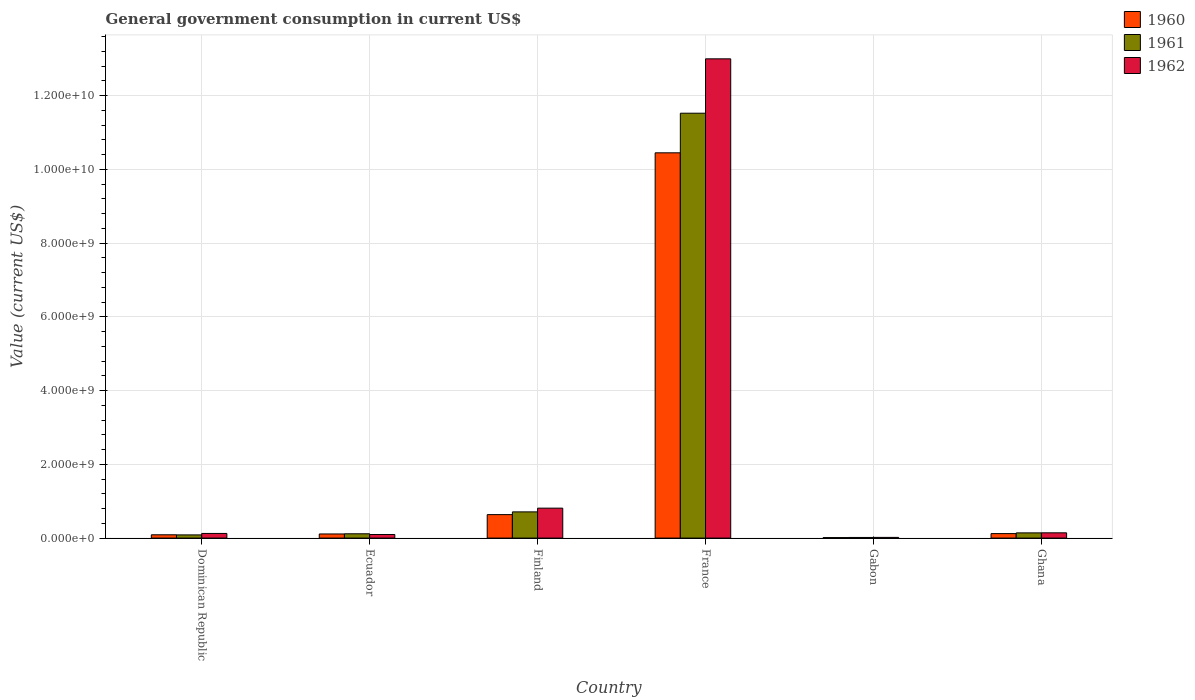How many different coloured bars are there?
Give a very brief answer. 3. Are the number of bars per tick equal to the number of legend labels?
Ensure brevity in your answer.  Yes. What is the label of the 6th group of bars from the left?
Your answer should be compact. Ghana. In how many cases, is the number of bars for a given country not equal to the number of legend labels?
Provide a succinct answer. 0. What is the government conusmption in 1962 in Ecuador?
Your answer should be compact. 9.72e+07. Across all countries, what is the maximum government conusmption in 1960?
Your response must be concise. 1.05e+1. Across all countries, what is the minimum government conusmption in 1962?
Your answer should be very brief. 1.86e+07. In which country was the government conusmption in 1960 maximum?
Keep it short and to the point. France. In which country was the government conusmption in 1961 minimum?
Ensure brevity in your answer.  Gabon. What is the total government conusmption in 1960 in the graph?
Provide a short and direct response. 1.14e+1. What is the difference between the government conusmption in 1961 in Finland and that in France?
Make the answer very short. -1.08e+1. What is the difference between the government conusmption in 1961 in Dominican Republic and the government conusmption in 1960 in Ecuador?
Keep it short and to the point. -2.52e+07. What is the average government conusmption in 1962 per country?
Your answer should be compact. 2.37e+09. What is the difference between the government conusmption of/in 1962 and government conusmption of/in 1960 in France?
Provide a short and direct response. 2.55e+09. In how many countries, is the government conusmption in 1962 greater than 2800000000 US$?
Provide a short and direct response. 1. What is the ratio of the government conusmption in 1962 in Finland to that in Gabon?
Make the answer very short. 43.55. What is the difference between the highest and the second highest government conusmption in 1962?
Provide a succinct answer. 6.69e+08. What is the difference between the highest and the lowest government conusmption in 1962?
Provide a short and direct response. 1.30e+1. In how many countries, is the government conusmption in 1961 greater than the average government conusmption in 1961 taken over all countries?
Make the answer very short. 1. Is the sum of the government conusmption in 1962 in Finland and Gabon greater than the maximum government conusmption in 1961 across all countries?
Make the answer very short. No. What does the 1st bar from the left in Gabon represents?
Offer a very short reply. 1960. Is it the case that in every country, the sum of the government conusmption in 1962 and government conusmption in 1961 is greater than the government conusmption in 1960?
Your response must be concise. Yes. How many bars are there?
Offer a terse response. 18. How many countries are there in the graph?
Your response must be concise. 6. What is the difference between two consecutive major ticks on the Y-axis?
Provide a succinct answer. 2.00e+09. Are the values on the major ticks of Y-axis written in scientific E-notation?
Offer a very short reply. Yes. Does the graph contain any zero values?
Ensure brevity in your answer.  No. Where does the legend appear in the graph?
Offer a very short reply. Top right. What is the title of the graph?
Offer a terse response. General government consumption in current US$. Does "1977" appear as one of the legend labels in the graph?
Your response must be concise. No. What is the label or title of the Y-axis?
Your answer should be compact. Value (current US$). What is the Value (current US$) in 1960 in Dominican Republic?
Your response must be concise. 8.95e+07. What is the Value (current US$) of 1961 in Dominican Republic?
Provide a short and direct response. 8.68e+07. What is the Value (current US$) of 1962 in Dominican Republic?
Offer a very short reply. 1.26e+08. What is the Value (current US$) in 1960 in Ecuador?
Provide a short and direct response. 1.12e+08. What is the Value (current US$) of 1961 in Ecuador?
Your answer should be compact. 1.17e+08. What is the Value (current US$) in 1962 in Ecuador?
Provide a succinct answer. 9.72e+07. What is the Value (current US$) of 1960 in Finland?
Your response must be concise. 6.37e+08. What is the Value (current US$) in 1961 in Finland?
Provide a short and direct response. 7.11e+08. What is the Value (current US$) of 1962 in Finland?
Offer a very short reply. 8.12e+08. What is the Value (current US$) in 1960 in France?
Make the answer very short. 1.05e+1. What is the Value (current US$) of 1961 in France?
Your answer should be compact. 1.15e+1. What is the Value (current US$) in 1962 in France?
Keep it short and to the point. 1.30e+1. What is the Value (current US$) in 1960 in Gabon?
Provide a succinct answer. 1.38e+07. What is the Value (current US$) in 1961 in Gabon?
Offer a terse response. 1.72e+07. What is the Value (current US$) in 1962 in Gabon?
Provide a short and direct response. 1.86e+07. What is the Value (current US$) in 1960 in Ghana?
Your response must be concise. 1.22e+08. What is the Value (current US$) in 1961 in Ghana?
Give a very brief answer. 1.41e+08. What is the Value (current US$) of 1962 in Ghana?
Offer a terse response. 1.43e+08. Across all countries, what is the maximum Value (current US$) in 1960?
Give a very brief answer. 1.05e+1. Across all countries, what is the maximum Value (current US$) in 1961?
Keep it short and to the point. 1.15e+1. Across all countries, what is the maximum Value (current US$) of 1962?
Your response must be concise. 1.30e+1. Across all countries, what is the minimum Value (current US$) in 1960?
Make the answer very short. 1.38e+07. Across all countries, what is the minimum Value (current US$) in 1961?
Make the answer very short. 1.72e+07. Across all countries, what is the minimum Value (current US$) in 1962?
Keep it short and to the point. 1.86e+07. What is the total Value (current US$) in 1960 in the graph?
Your answer should be very brief. 1.14e+1. What is the total Value (current US$) of 1961 in the graph?
Give a very brief answer. 1.26e+1. What is the total Value (current US$) of 1962 in the graph?
Provide a succinct answer. 1.42e+1. What is the difference between the Value (current US$) of 1960 in Dominican Republic and that in Ecuador?
Make the answer very short. -2.25e+07. What is the difference between the Value (current US$) in 1961 in Dominican Republic and that in Ecuador?
Keep it short and to the point. -2.99e+07. What is the difference between the Value (current US$) of 1962 in Dominican Republic and that in Ecuador?
Offer a terse response. 2.89e+07. What is the difference between the Value (current US$) in 1960 in Dominican Republic and that in Finland?
Provide a succinct answer. -5.47e+08. What is the difference between the Value (current US$) of 1961 in Dominican Republic and that in Finland?
Your answer should be compact. -6.24e+08. What is the difference between the Value (current US$) in 1962 in Dominican Republic and that in Finland?
Keep it short and to the point. -6.86e+08. What is the difference between the Value (current US$) in 1960 in Dominican Republic and that in France?
Provide a short and direct response. -1.04e+1. What is the difference between the Value (current US$) of 1961 in Dominican Republic and that in France?
Provide a short and direct response. -1.14e+1. What is the difference between the Value (current US$) in 1962 in Dominican Republic and that in France?
Your answer should be compact. -1.29e+1. What is the difference between the Value (current US$) in 1960 in Dominican Republic and that in Gabon?
Make the answer very short. 7.57e+07. What is the difference between the Value (current US$) of 1961 in Dominican Republic and that in Gabon?
Ensure brevity in your answer.  6.96e+07. What is the difference between the Value (current US$) in 1962 in Dominican Republic and that in Gabon?
Keep it short and to the point. 1.07e+08. What is the difference between the Value (current US$) in 1960 in Dominican Republic and that in Ghana?
Ensure brevity in your answer.  -3.24e+07. What is the difference between the Value (current US$) of 1961 in Dominican Republic and that in Ghana?
Offer a terse response. -5.47e+07. What is the difference between the Value (current US$) of 1962 in Dominican Republic and that in Ghana?
Make the answer very short. -1.68e+07. What is the difference between the Value (current US$) in 1960 in Ecuador and that in Finland?
Offer a very short reply. -5.25e+08. What is the difference between the Value (current US$) in 1961 in Ecuador and that in Finland?
Keep it short and to the point. -5.94e+08. What is the difference between the Value (current US$) in 1962 in Ecuador and that in Finland?
Offer a terse response. -7.15e+08. What is the difference between the Value (current US$) in 1960 in Ecuador and that in France?
Ensure brevity in your answer.  -1.03e+1. What is the difference between the Value (current US$) in 1961 in Ecuador and that in France?
Keep it short and to the point. -1.14e+1. What is the difference between the Value (current US$) of 1962 in Ecuador and that in France?
Your answer should be compact. -1.29e+1. What is the difference between the Value (current US$) in 1960 in Ecuador and that in Gabon?
Offer a terse response. 9.82e+07. What is the difference between the Value (current US$) of 1961 in Ecuador and that in Gabon?
Ensure brevity in your answer.  9.95e+07. What is the difference between the Value (current US$) in 1962 in Ecuador and that in Gabon?
Ensure brevity in your answer.  7.86e+07. What is the difference between the Value (current US$) of 1960 in Ecuador and that in Ghana?
Keep it short and to the point. -9.85e+06. What is the difference between the Value (current US$) of 1961 in Ecuador and that in Ghana?
Provide a short and direct response. -2.48e+07. What is the difference between the Value (current US$) in 1962 in Ecuador and that in Ghana?
Give a very brief answer. -4.56e+07. What is the difference between the Value (current US$) in 1960 in Finland and that in France?
Keep it short and to the point. -9.81e+09. What is the difference between the Value (current US$) of 1961 in Finland and that in France?
Keep it short and to the point. -1.08e+1. What is the difference between the Value (current US$) of 1962 in Finland and that in France?
Ensure brevity in your answer.  -1.22e+1. What is the difference between the Value (current US$) of 1960 in Finland and that in Gabon?
Ensure brevity in your answer.  6.23e+08. What is the difference between the Value (current US$) of 1961 in Finland and that in Gabon?
Make the answer very short. 6.94e+08. What is the difference between the Value (current US$) in 1962 in Finland and that in Gabon?
Keep it short and to the point. 7.94e+08. What is the difference between the Value (current US$) in 1960 in Finland and that in Ghana?
Your answer should be compact. 5.15e+08. What is the difference between the Value (current US$) in 1961 in Finland and that in Ghana?
Your answer should be very brief. 5.69e+08. What is the difference between the Value (current US$) in 1962 in Finland and that in Ghana?
Keep it short and to the point. 6.69e+08. What is the difference between the Value (current US$) of 1960 in France and that in Gabon?
Your answer should be very brief. 1.04e+1. What is the difference between the Value (current US$) in 1961 in France and that in Gabon?
Offer a terse response. 1.15e+1. What is the difference between the Value (current US$) in 1962 in France and that in Gabon?
Offer a very short reply. 1.30e+1. What is the difference between the Value (current US$) in 1960 in France and that in Ghana?
Your response must be concise. 1.03e+1. What is the difference between the Value (current US$) of 1961 in France and that in Ghana?
Make the answer very short. 1.14e+1. What is the difference between the Value (current US$) in 1962 in France and that in Ghana?
Your response must be concise. 1.29e+1. What is the difference between the Value (current US$) of 1960 in Gabon and that in Ghana?
Your answer should be very brief. -1.08e+08. What is the difference between the Value (current US$) in 1961 in Gabon and that in Ghana?
Ensure brevity in your answer.  -1.24e+08. What is the difference between the Value (current US$) of 1962 in Gabon and that in Ghana?
Provide a succinct answer. -1.24e+08. What is the difference between the Value (current US$) of 1960 in Dominican Republic and the Value (current US$) of 1961 in Ecuador?
Ensure brevity in your answer.  -2.72e+07. What is the difference between the Value (current US$) of 1960 in Dominican Republic and the Value (current US$) of 1962 in Ecuador?
Give a very brief answer. -7.73e+06. What is the difference between the Value (current US$) in 1961 in Dominican Republic and the Value (current US$) in 1962 in Ecuador?
Your answer should be very brief. -1.04e+07. What is the difference between the Value (current US$) in 1960 in Dominican Republic and the Value (current US$) in 1961 in Finland?
Provide a short and direct response. -6.21e+08. What is the difference between the Value (current US$) in 1960 in Dominican Republic and the Value (current US$) in 1962 in Finland?
Your answer should be compact. -7.23e+08. What is the difference between the Value (current US$) in 1961 in Dominican Republic and the Value (current US$) in 1962 in Finland?
Offer a very short reply. -7.25e+08. What is the difference between the Value (current US$) of 1960 in Dominican Republic and the Value (current US$) of 1961 in France?
Your response must be concise. -1.14e+1. What is the difference between the Value (current US$) in 1960 in Dominican Republic and the Value (current US$) in 1962 in France?
Offer a terse response. -1.29e+1. What is the difference between the Value (current US$) of 1961 in Dominican Republic and the Value (current US$) of 1962 in France?
Keep it short and to the point. -1.29e+1. What is the difference between the Value (current US$) of 1960 in Dominican Republic and the Value (current US$) of 1961 in Gabon?
Offer a very short reply. 7.23e+07. What is the difference between the Value (current US$) in 1960 in Dominican Republic and the Value (current US$) in 1962 in Gabon?
Provide a short and direct response. 7.09e+07. What is the difference between the Value (current US$) of 1961 in Dominican Republic and the Value (current US$) of 1962 in Gabon?
Offer a very short reply. 6.82e+07. What is the difference between the Value (current US$) in 1960 in Dominican Republic and the Value (current US$) in 1961 in Ghana?
Your answer should be very brief. -5.20e+07. What is the difference between the Value (current US$) in 1960 in Dominican Republic and the Value (current US$) in 1962 in Ghana?
Provide a succinct answer. -5.34e+07. What is the difference between the Value (current US$) of 1961 in Dominican Republic and the Value (current US$) of 1962 in Ghana?
Make the answer very short. -5.61e+07. What is the difference between the Value (current US$) in 1960 in Ecuador and the Value (current US$) in 1961 in Finland?
Your answer should be very brief. -5.99e+08. What is the difference between the Value (current US$) of 1960 in Ecuador and the Value (current US$) of 1962 in Finland?
Provide a succinct answer. -7.00e+08. What is the difference between the Value (current US$) of 1961 in Ecuador and the Value (current US$) of 1962 in Finland?
Keep it short and to the point. -6.95e+08. What is the difference between the Value (current US$) in 1960 in Ecuador and the Value (current US$) in 1961 in France?
Keep it short and to the point. -1.14e+1. What is the difference between the Value (current US$) in 1960 in Ecuador and the Value (current US$) in 1962 in France?
Your answer should be compact. -1.29e+1. What is the difference between the Value (current US$) in 1961 in Ecuador and the Value (current US$) in 1962 in France?
Keep it short and to the point. -1.29e+1. What is the difference between the Value (current US$) of 1960 in Ecuador and the Value (current US$) of 1961 in Gabon?
Your response must be concise. 9.48e+07. What is the difference between the Value (current US$) in 1960 in Ecuador and the Value (current US$) in 1962 in Gabon?
Offer a very short reply. 9.34e+07. What is the difference between the Value (current US$) in 1961 in Ecuador and the Value (current US$) in 1962 in Gabon?
Give a very brief answer. 9.80e+07. What is the difference between the Value (current US$) of 1960 in Ecuador and the Value (current US$) of 1961 in Ghana?
Your response must be concise. -2.95e+07. What is the difference between the Value (current US$) of 1960 in Ecuador and the Value (current US$) of 1962 in Ghana?
Provide a succinct answer. -3.09e+07. What is the difference between the Value (current US$) of 1961 in Ecuador and the Value (current US$) of 1962 in Ghana?
Your answer should be very brief. -2.62e+07. What is the difference between the Value (current US$) of 1960 in Finland and the Value (current US$) of 1961 in France?
Your response must be concise. -1.09e+1. What is the difference between the Value (current US$) of 1960 in Finland and the Value (current US$) of 1962 in France?
Ensure brevity in your answer.  -1.24e+1. What is the difference between the Value (current US$) of 1961 in Finland and the Value (current US$) of 1962 in France?
Offer a very short reply. -1.23e+1. What is the difference between the Value (current US$) of 1960 in Finland and the Value (current US$) of 1961 in Gabon?
Your response must be concise. 6.20e+08. What is the difference between the Value (current US$) of 1960 in Finland and the Value (current US$) of 1962 in Gabon?
Your response must be concise. 6.18e+08. What is the difference between the Value (current US$) of 1961 in Finland and the Value (current US$) of 1962 in Gabon?
Keep it short and to the point. 6.92e+08. What is the difference between the Value (current US$) in 1960 in Finland and the Value (current US$) in 1961 in Ghana?
Keep it short and to the point. 4.95e+08. What is the difference between the Value (current US$) in 1960 in Finland and the Value (current US$) in 1962 in Ghana?
Give a very brief answer. 4.94e+08. What is the difference between the Value (current US$) of 1961 in Finland and the Value (current US$) of 1962 in Ghana?
Keep it short and to the point. 5.68e+08. What is the difference between the Value (current US$) in 1960 in France and the Value (current US$) in 1961 in Gabon?
Offer a terse response. 1.04e+1. What is the difference between the Value (current US$) of 1960 in France and the Value (current US$) of 1962 in Gabon?
Offer a very short reply. 1.04e+1. What is the difference between the Value (current US$) in 1961 in France and the Value (current US$) in 1962 in Gabon?
Offer a very short reply. 1.15e+1. What is the difference between the Value (current US$) in 1960 in France and the Value (current US$) in 1961 in Ghana?
Offer a terse response. 1.03e+1. What is the difference between the Value (current US$) of 1960 in France and the Value (current US$) of 1962 in Ghana?
Provide a short and direct response. 1.03e+1. What is the difference between the Value (current US$) of 1961 in France and the Value (current US$) of 1962 in Ghana?
Your answer should be very brief. 1.14e+1. What is the difference between the Value (current US$) of 1960 in Gabon and the Value (current US$) of 1961 in Ghana?
Give a very brief answer. -1.28e+08. What is the difference between the Value (current US$) of 1960 in Gabon and the Value (current US$) of 1962 in Ghana?
Your response must be concise. -1.29e+08. What is the difference between the Value (current US$) in 1961 in Gabon and the Value (current US$) in 1962 in Ghana?
Keep it short and to the point. -1.26e+08. What is the average Value (current US$) in 1960 per country?
Offer a very short reply. 1.90e+09. What is the average Value (current US$) of 1961 per country?
Make the answer very short. 2.10e+09. What is the average Value (current US$) in 1962 per country?
Your response must be concise. 2.37e+09. What is the difference between the Value (current US$) of 1960 and Value (current US$) of 1961 in Dominican Republic?
Make the answer very short. 2.70e+06. What is the difference between the Value (current US$) of 1960 and Value (current US$) of 1962 in Dominican Republic?
Your response must be concise. -3.66e+07. What is the difference between the Value (current US$) in 1961 and Value (current US$) in 1962 in Dominican Republic?
Your answer should be very brief. -3.93e+07. What is the difference between the Value (current US$) in 1960 and Value (current US$) in 1961 in Ecuador?
Make the answer very short. -4.67e+06. What is the difference between the Value (current US$) of 1960 and Value (current US$) of 1962 in Ecuador?
Keep it short and to the point. 1.48e+07. What is the difference between the Value (current US$) of 1961 and Value (current US$) of 1962 in Ecuador?
Offer a very short reply. 1.94e+07. What is the difference between the Value (current US$) of 1960 and Value (current US$) of 1961 in Finland?
Your response must be concise. -7.42e+07. What is the difference between the Value (current US$) in 1960 and Value (current US$) in 1962 in Finland?
Give a very brief answer. -1.75e+08. What is the difference between the Value (current US$) of 1961 and Value (current US$) of 1962 in Finland?
Ensure brevity in your answer.  -1.01e+08. What is the difference between the Value (current US$) of 1960 and Value (current US$) of 1961 in France?
Give a very brief answer. -1.07e+09. What is the difference between the Value (current US$) in 1960 and Value (current US$) in 1962 in France?
Your response must be concise. -2.55e+09. What is the difference between the Value (current US$) in 1961 and Value (current US$) in 1962 in France?
Provide a succinct answer. -1.48e+09. What is the difference between the Value (current US$) in 1960 and Value (current US$) in 1961 in Gabon?
Your response must be concise. -3.38e+06. What is the difference between the Value (current US$) in 1960 and Value (current US$) in 1962 in Gabon?
Your answer should be compact. -4.81e+06. What is the difference between the Value (current US$) in 1961 and Value (current US$) in 1962 in Gabon?
Offer a very short reply. -1.43e+06. What is the difference between the Value (current US$) in 1960 and Value (current US$) in 1961 in Ghana?
Your response must be concise. -1.96e+07. What is the difference between the Value (current US$) in 1960 and Value (current US$) in 1962 in Ghana?
Make the answer very short. -2.10e+07. What is the difference between the Value (current US$) in 1961 and Value (current US$) in 1962 in Ghana?
Offer a very short reply. -1.40e+06. What is the ratio of the Value (current US$) in 1960 in Dominican Republic to that in Ecuador?
Keep it short and to the point. 0.8. What is the ratio of the Value (current US$) in 1961 in Dominican Republic to that in Ecuador?
Provide a short and direct response. 0.74. What is the ratio of the Value (current US$) of 1962 in Dominican Republic to that in Ecuador?
Your answer should be compact. 1.3. What is the ratio of the Value (current US$) in 1960 in Dominican Republic to that in Finland?
Ensure brevity in your answer.  0.14. What is the ratio of the Value (current US$) of 1961 in Dominican Republic to that in Finland?
Ensure brevity in your answer.  0.12. What is the ratio of the Value (current US$) in 1962 in Dominican Republic to that in Finland?
Offer a terse response. 0.16. What is the ratio of the Value (current US$) in 1960 in Dominican Republic to that in France?
Offer a terse response. 0.01. What is the ratio of the Value (current US$) of 1961 in Dominican Republic to that in France?
Your response must be concise. 0.01. What is the ratio of the Value (current US$) in 1962 in Dominican Republic to that in France?
Keep it short and to the point. 0.01. What is the ratio of the Value (current US$) of 1960 in Dominican Republic to that in Gabon?
Offer a very short reply. 6.47. What is the ratio of the Value (current US$) of 1961 in Dominican Republic to that in Gabon?
Keep it short and to the point. 5.04. What is the ratio of the Value (current US$) of 1962 in Dominican Republic to that in Gabon?
Offer a terse response. 6.76. What is the ratio of the Value (current US$) in 1960 in Dominican Republic to that in Ghana?
Your answer should be very brief. 0.73. What is the ratio of the Value (current US$) in 1961 in Dominican Republic to that in Ghana?
Provide a short and direct response. 0.61. What is the ratio of the Value (current US$) of 1962 in Dominican Republic to that in Ghana?
Ensure brevity in your answer.  0.88. What is the ratio of the Value (current US$) of 1960 in Ecuador to that in Finland?
Your answer should be compact. 0.18. What is the ratio of the Value (current US$) of 1961 in Ecuador to that in Finland?
Make the answer very short. 0.16. What is the ratio of the Value (current US$) in 1962 in Ecuador to that in Finland?
Your answer should be compact. 0.12. What is the ratio of the Value (current US$) of 1960 in Ecuador to that in France?
Your answer should be compact. 0.01. What is the ratio of the Value (current US$) in 1961 in Ecuador to that in France?
Offer a terse response. 0.01. What is the ratio of the Value (current US$) in 1962 in Ecuador to that in France?
Offer a very short reply. 0.01. What is the ratio of the Value (current US$) of 1960 in Ecuador to that in Gabon?
Offer a very short reply. 8.1. What is the ratio of the Value (current US$) of 1961 in Ecuador to that in Gabon?
Make the answer very short. 6.78. What is the ratio of the Value (current US$) in 1962 in Ecuador to that in Gabon?
Make the answer very short. 5.21. What is the ratio of the Value (current US$) in 1960 in Ecuador to that in Ghana?
Provide a succinct answer. 0.92. What is the ratio of the Value (current US$) in 1961 in Ecuador to that in Ghana?
Your response must be concise. 0.82. What is the ratio of the Value (current US$) in 1962 in Ecuador to that in Ghana?
Offer a terse response. 0.68. What is the ratio of the Value (current US$) of 1960 in Finland to that in France?
Your response must be concise. 0.06. What is the ratio of the Value (current US$) in 1961 in Finland to that in France?
Provide a short and direct response. 0.06. What is the ratio of the Value (current US$) in 1962 in Finland to that in France?
Make the answer very short. 0.06. What is the ratio of the Value (current US$) of 1960 in Finland to that in Gabon?
Make the answer very short. 46.02. What is the ratio of the Value (current US$) in 1961 in Finland to that in Gabon?
Make the answer very short. 41.29. What is the ratio of the Value (current US$) of 1962 in Finland to that in Gabon?
Make the answer very short. 43.55. What is the ratio of the Value (current US$) in 1960 in Finland to that in Ghana?
Make the answer very short. 5.22. What is the ratio of the Value (current US$) in 1961 in Finland to that in Ghana?
Your answer should be very brief. 5.03. What is the ratio of the Value (current US$) in 1962 in Finland to that in Ghana?
Make the answer very short. 5.68. What is the ratio of the Value (current US$) in 1960 in France to that in Gabon?
Offer a very short reply. 755.44. What is the ratio of the Value (current US$) in 1961 in France to that in Gabon?
Provide a short and direct response. 669.38. What is the ratio of the Value (current US$) in 1962 in France to that in Gabon?
Give a very brief answer. 697.15. What is the ratio of the Value (current US$) of 1960 in France to that in Ghana?
Your answer should be very brief. 85.77. What is the ratio of the Value (current US$) of 1961 in France to that in Ghana?
Keep it short and to the point. 81.47. What is the ratio of the Value (current US$) of 1962 in France to that in Ghana?
Keep it short and to the point. 91. What is the ratio of the Value (current US$) of 1960 in Gabon to that in Ghana?
Offer a very short reply. 0.11. What is the ratio of the Value (current US$) of 1961 in Gabon to that in Ghana?
Give a very brief answer. 0.12. What is the ratio of the Value (current US$) in 1962 in Gabon to that in Ghana?
Your answer should be very brief. 0.13. What is the difference between the highest and the second highest Value (current US$) in 1960?
Make the answer very short. 9.81e+09. What is the difference between the highest and the second highest Value (current US$) in 1961?
Offer a very short reply. 1.08e+1. What is the difference between the highest and the second highest Value (current US$) in 1962?
Give a very brief answer. 1.22e+1. What is the difference between the highest and the lowest Value (current US$) in 1960?
Your response must be concise. 1.04e+1. What is the difference between the highest and the lowest Value (current US$) of 1961?
Your answer should be very brief. 1.15e+1. What is the difference between the highest and the lowest Value (current US$) of 1962?
Make the answer very short. 1.30e+1. 